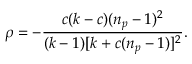<formula> <loc_0><loc_0><loc_500><loc_500>\rho = - \frac { c ( k - c ) ( n _ { p } - 1 ) ^ { 2 } } { ( k - 1 ) [ k + c ( n _ { p } - 1 ) ] ^ { 2 } } .</formula> 